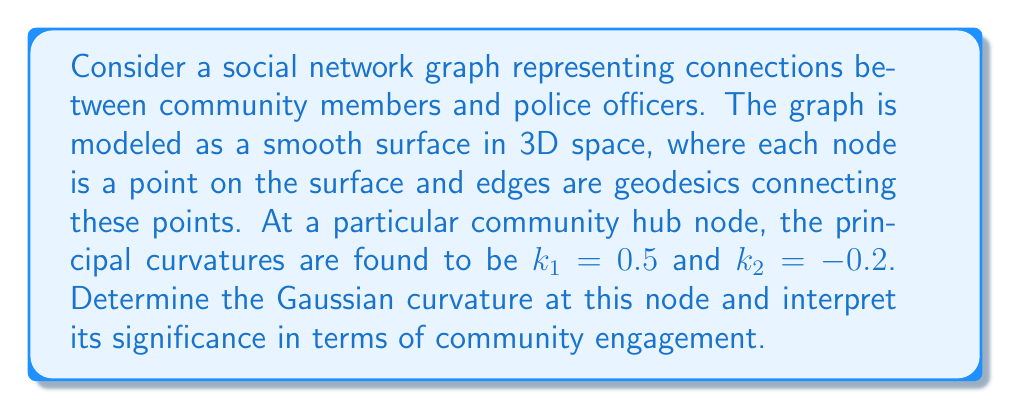Could you help me with this problem? To solve this problem, we'll follow these steps:

1) Recall the definition of Gaussian curvature:
   The Gaussian curvature $K$ at a point on a surface is the product of the principal curvatures at that point.

   $$K = k_1 \cdot k_2$$

2) We are given the principal curvatures:
   $k_1 = 0.5$ and $k_2 = -0.2$

3) Let's substitute these values into the formula:

   $$K = 0.5 \cdot (-0.2) = -0.1$$

4) Interpretation:
   - The negative Gaussian curvature (-0.1) indicates that this point on the surface has a saddle-like shape.
   - In the context of our social network:
     a) This suggests that the community hub connects different groups that might not otherwise interact.
     b) It implies that this node acts as a bridge between diverse community segments and the police force.
     c) The hub likely facilitates information flow and interactions between multiple subgroups.

5) For a tech-savvy community organizer, this information can be used to:
   - Identify key nodes for disseminating information or initiating community programs.
   - Focus on strengthening connections through this hub to improve overall community-police relations.
   - Develop targeted communication strategies that leverage this node's central position in the network.
Answer: $K = -0.1$ 